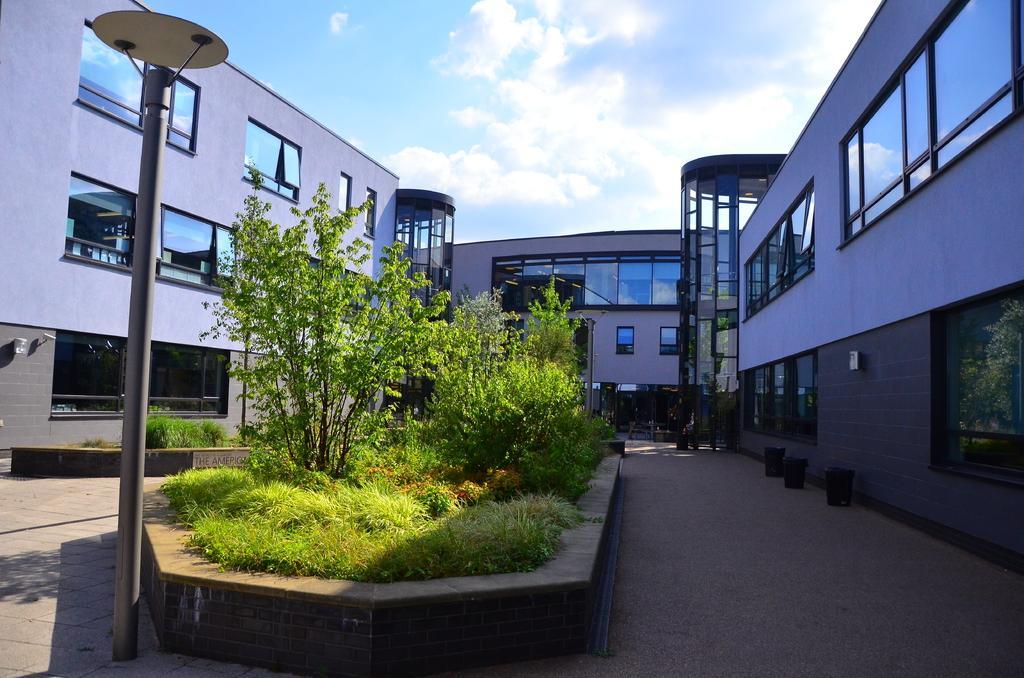Describe this image in one or two sentences. This image consists of a building along with windows. In the middle, there are plants. At the bottom, there is a road. 